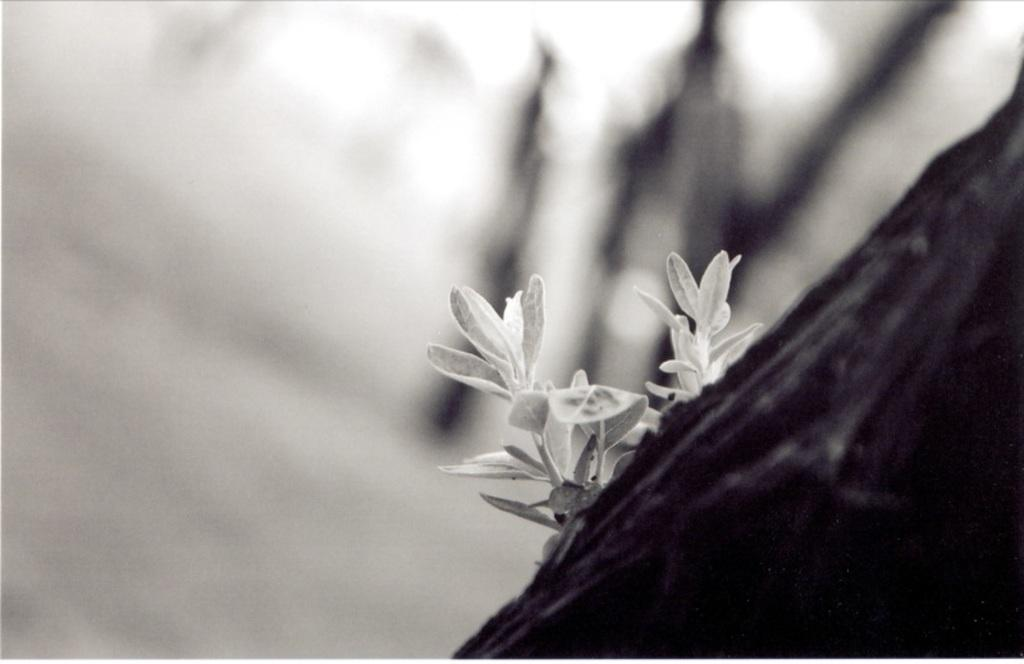What is the main subject of the image? The main subject of the image is the leaves of a plant. Can you describe the background of the image? The background of the image is blurry. What type of headphones can be seen in the image? There are no headphones present in the image; it features leaves of a plant with a blurry background. What is the plant learning in the image? Plants do not learn in the same way as humans or animals, so this question cannot be answered definitively based on the image. 